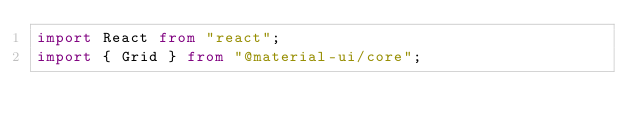Convert code to text. <code><loc_0><loc_0><loc_500><loc_500><_TypeScript_>import React from "react";
import { Grid } from "@material-ui/core";</code> 